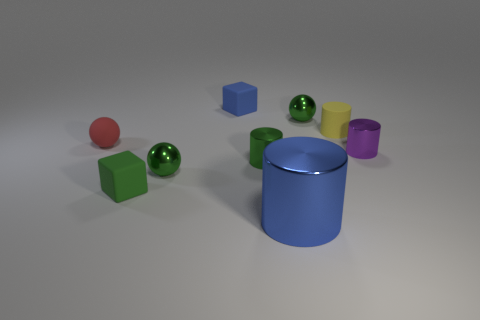Subtract all tiny green shiny balls. How many balls are left? 1 Subtract all green blocks. How many green balls are left? 2 Add 1 cubes. How many objects exist? 10 Subtract all purple cylinders. How many cylinders are left? 3 Subtract 1 balls. How many balls are left? 2 Subtract 0 gray cylinders. How many objects are left? 9 Subtract all cylinders. How many objects are left? 5 Subtract all yellow spheres. Subtract all gray blocks. How many spheres are left? 3 Subtract all big blue metal objects. Subtract all small red rubber balls. How many objects are left? 7 Add 7 small red things. How many small red things are left? 8 